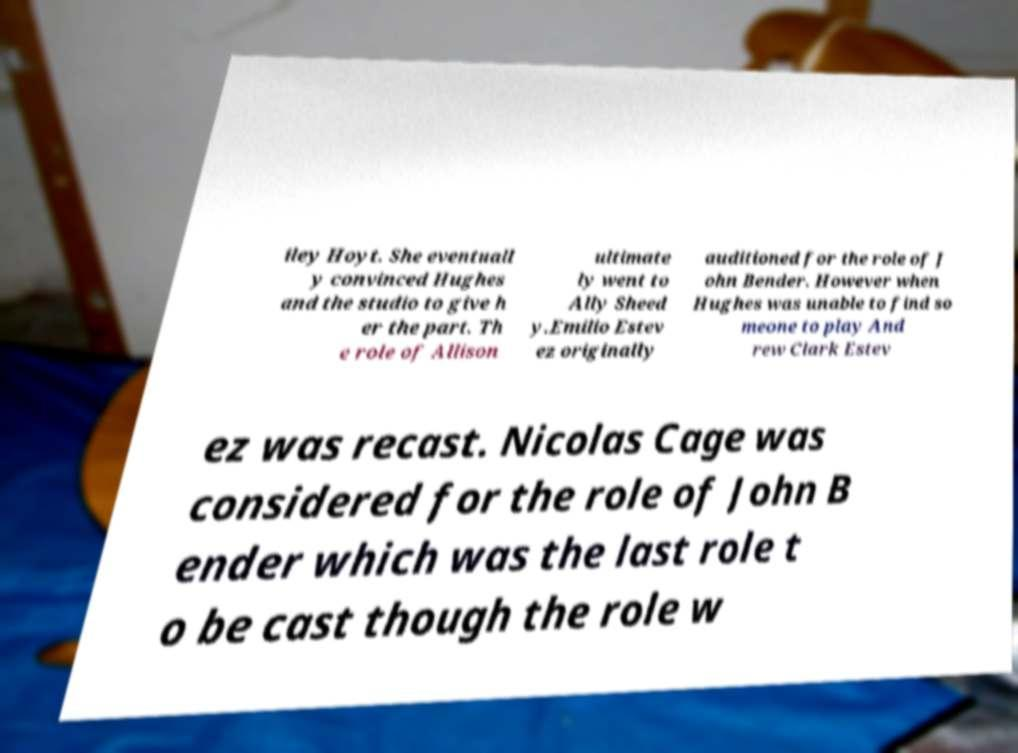I need the written content from this picture converted into text. Can you do that? iley Hoyt. She eventuall y convinced Hughes and the studio to give h er the part. Th e role of Allison ultimate ly went to Ally Sheed y.Emilio Estev ez originally auditioned for the role of J ohn Bender. However when Hughes was unable to find so meone to play And rew Clark Estev ez was recast. Nicolas Cage was considered for the role of John B ender which was the last role t o be cast though the role w 